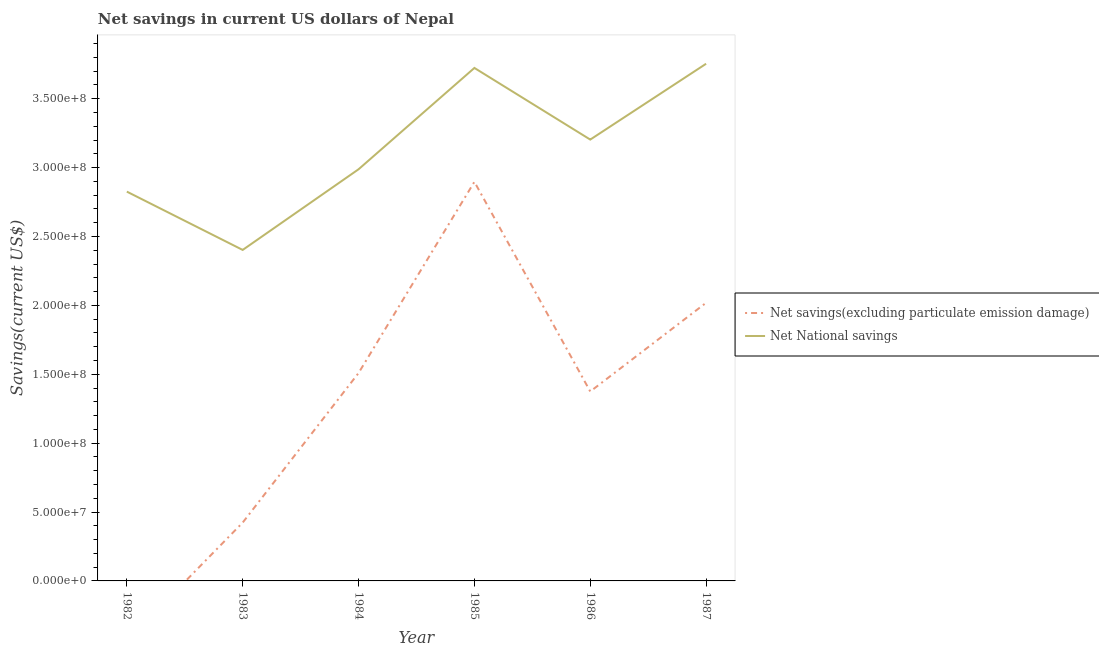How many different coloured lines are there?
Ensure brevity in your answer.  2. Does the line corresponding to net savings(excluding particulate emission damage) intersect with the line corresponding to net national savings?
Provide a short and direct response. No. Is the number of lines equal to the number of legend labels?
Offer a terse response. No. What is the net national savings in 1987?
Provide a succinct answer. 3.75e+08. Across all years, what is the maximum net savings(excluding particulate emission damage)?
Provide a short and direct response. 2.90e+08. Across all years, what is the minimum net national savings?
Your response must be concise. 2.40e+08. In which year was the net national savings maximum?
Keep it short and to the point. 1987. What is the total net national savings in the graph?
Provide a short and direct response. 1.89e+09. What is the difference between the net savings(excluding particulate emission damage) in 1983 and that in 1984?
Provide a short and direct response. -1.09e+08. What is the difference between the net savings(excluding particulate emission damage) in 1984 and the net national savings in 1985?
Provide a short and direct response. -2.21e+08. What is the average net savings(excluding particulate emission damage) per year?
Offer a very short reply. 1.37e+08. In the year 1986, what is the difference between the net national savings and net savings(excluding particulate emission damage)?
Ensure brevity in your answer.  1.83e+08. What is the ratio of the net savings(excluding particulate emission damage) in 1983 to that in 1984?
Provide a succinct answer. 0.28. Is the difference between the net savings(excluding particulate emission damage) in 1983 and 1984 greater than the difference between the net national savings in 1983 and 1984?
Provide a succinct answer. No. What is the difference between the highest and the second highest net savings(excluding particulate emission damage)?
Provide a short and direct response. 8.78e+07. What is the difference between the highest and the lowest net national savings?
Make the answer very short. 1.35e+08. How many lines are there?
Offer a terse response. 2. Are the values on the major ticks of Y-axis written in scientific E-notation?
Make the answer very short. Yes. How many legend labels are there?
Offer a terse response. 2. What is the title of the graph?
Provide a succinct answer. Net savings in current US dollars of Nepal. Does "Revenue" appear as one of the legend labels in the graph?
Keep it short and to the point. No. What is the label or title of the X-axis?
Keep it short and to the point. Year. What is the label or title of the Y-axis?
Make the answer very short. Savings(current US$). What is the Savings(current US$) in Net savings(excluding particulate emission damage) in 1982?
Your response must be concise. 0. What is the Savings(current US$) of Net National savings in 1982?
Offer a very short reply. 2.83e+08. What is the Savings(current US$) in Net savings(excluding particulate emission damage) in 1983?
Give a very brief answer. 4.23e+07. What is the Savings(current US$) in Net National savings in 1983?
Your answer should be very brief. 2.40e+08. What is the Savings(current US$) of Net savings(excluding particulate emission damage) in 1984?
Give a very brief answer. 1.51e+08. What is the Savings(current US$) in Net National savings in 1984?
Your answer should be very brief. 2.99e+08. What is the Savings(current US$) in Net savings(excluding particulate emission damage) in 1985?
Provide a succinct answer. 2.90e+08. What is the Savings(current US$) of Net National savings in 1985?
Give a very brief answer. 3.72e+08. What is the Savings(current US$) of Net savings(excluding particulate emission damage) in 1986?
Ensure brevity in your answer.  1.38e+08. What is the Savings(current US$) in Net National savings in 1986?
Ensure brevity in your answer.  3.20e+08. What is the Savings(current US$) of Net savings(excluding particulate emission damage) in 1987?
Ensure brevity in your answer.  2.02e+08. What is the Savings(current US$) in Net National savings in 1987?
Provide a succinct answer. 3.75e+08. Across all years, what is the maximum Savings(current US$) in Net savings(excluding particulate emission damage)?
Provide a short and direct response. 2.90e+08. Across all years, what is the maximum Savings(current US$) of Net National savings?
Offer a terse response. 3.75e+08. Across all years, what is the minimum Savings(current US$) in Net National savings?
Keep it short and to the point. 2.40e+08. What is the total Savings(current US$) of Net savings(excluding particulate emission damage) in the graph?
Ensure brevity in your answer.  8.22e+08. What is the total Savings(current US$) of Net National savings in the graph?
Keep it short and to the point. 1.89e+09. What is the difference between the Savings(current US$) in Net National savings in 1982 and that in 1983?
Your response must be concise. 4.23e+07. What is the difference between the Savings(current US$) in Net National savings in 1982 and that in 1984?
Offer a terse response. -1.62e+07. What is the difference between the Savings(current US$) in Net National savings in 1982 and that in 1985?
Your answer should be compact. -8.98e+07. What is the difference between the Savings(current US$) in Net National savings in 1982 and that in 1986?
Provide a succinct answer. -3.78e+07. What is the difference between the Savings(current US$) of Net National savings in 1982 and that in 1987?
Ensure brevity in your answer.  -9.28e+07. What is the difference between the Savings(current US$) in Net savings(excluding particulate emission damage) in 1983 and that in 1984?
Ensure brevity in your answer.  -1.09e+08. What is the difference between the Savings(current US$) of Net National savings in 1983 and that in 1984?
Your answer should be compact. -5.85e+07. What is the difference between the Savings(current US$) of Net savings(excluding particulate emission damage) in 1983 and that in 1985?
Make the answer very short. -2.47e+08. What is the difference between the Savings(current US$) of Net National savings in 1983 and that in 1985?
Offer a terse response. -1.32e+08. What is the difference between the Savings(current US$) of Net savings(excluding particulate emission damage) in 1983 and that in 1986?
Ensure brevity in your answer.  -9.52e+07. What is the difference between the Savings(current US$) of Net National savings in 1983 and that in 1986?
Give a very brief answer. -8.01e+07. What is the difference between the Savings(current US$) of Net savings(excluding particulate emission damage) in 1983 and that in 1987?
Provide a succinct answer. -1.60e+08. What is the difference between the Savings(current US$) in Net National savings in 1983 and that in 1987?
Offer a very short reply. -1.35e+08. What is the difference between the Savings(current US$) in Net savings(excluding particulate emission damage) in 1984 and that in 1985?
Give a very brief answer. -1.39e+08. What is the difference between the Savings(current US$) in Net National savings in 1984 and that in 1985?
Give a very brief answer. -7.36e+07. What is the difference between the Savings(current US$) in Net savings(excluding particulate emission damage) in 1984 and that in 1986?
Your answer should be very brief. 1.34e+07. What is the difference between the Savings(current US$) of Net National savings in 1984 and that in 1986?
Offer a terse response. -2.16e+07. What is the difference between the Savings(current US$) in Net savings(excluding particulate emission damage) in 1984 and that in 1987?
Provide a succinct answer. -5.10e+07. What is the difference between the Savings(current US$) in Net National savings in 1984 and that in 1987?
Your answer should be compact. -7.66e+07. What is the difference between the Savings(current US$) in Net savings(excluding particulate emission damage) in 1985 and that in 1986?
Offer a very short reply. 1.52e+08. What is the difference between the Savings(current US$) of Net National savings in 1985 and that in 1986?
Keep it short and to the point. 5.20e+07. What is the difference between the Savings(current US$) of Net savings(excluding particulate emission damage) in 1985 and that in 1987?
Give a very brief answer. 8.78e+07. What is the difference between the Savings(current US$) of Net National savings in 1985 and that in 1987?
Offer a very short reply. -3.04e+06. What is the difference between the Savings(current US$) of Net savings(excluding particulate emission damage) in 1986 and that in 1987?
Your answer should be compact. -6.44e+07. What is the difference between the Savings(current US$) of Net National savings in 1986 and that in 1987?
Keep it short and to the point. -5.51e+07. What is the difference between the Savings(current US$) of Net savings(excluding particulate emission damage) in 1983 and the Savings(current US$) of Net National savings in 1984?
Offer a terse response. -2.56e+08. What is the difference between the Savings(current US$) in Net savings(excluding particulate emission damage) in 1983 and the Savings(current US$) in Net National savings in 1985?
Provide a succinct answer. -3.30e+08. What is the difference between the Savings(current US$) in Net savings(excluding particulate emission damage) in 1983 and the Savings(current US$) in Net National savings in 1986?
Make the answer very short. -2.78e+08. What is the difference between the Savings(current US$) in Net savings(excluding particulate emission damage) in 1983 and the Savings(current US$) in Net National savings in 1987?
Ensure brevity in your answer.  -3.33e+08. What is the difference between the Savings(current US$) in Net savings(excluding particulate emission damage) in 1984 and the Savings(current US$) in Net National savings in 1985?
Give a very brief answer. -2.21e+08. What is the difference between the Savings(current US$) of Net savings(excluding particulate emission damage) in 1984 and the Savings(current US$) of Net National savings in 1986?
Keep it short and to the point. -1.69e+08. What is the difference between the Savings(current US$) in Net savings(excluding particulate emission damage) in 1984 and the Savings(current US$) in Net National savings in 1987?
Provide a succinct answer. -2.24e+08. What is the difference between the Savings(current US$) in Net savings(excluding particulate emission damage) in 1985 and the Savings(current US$) in Net National savings in 1986?
Offer a terse response. -3.07e+07. What is the difference between the Savings(current US$) in Net savings(excluding particulate emission damage) in 1985 and the Savings(current US$) in Net National savings in 1987?
Your answer should be very brief. -8.57e+07. What is the difference between the Savings(current US$) of Net savings(excluding particulate emission damage) in 1986 and the Savings(current US$) of Net National savings in 1987?
Your answer should be compact. -2.38e+08. What is the average Savings(current US$) of Net savings(excluding particulate emission damage) per year?
Your answer should be compact. 1.37e+08. What is the average Savings(current US$) of Net National savings per year?
Your response must be concise. 3.15e+08. In the year 1983, what is the difference between the Savings(current US$) in Net savings(excluding particulate emission damage) and Savings(current US$) in Net National savings?
Keep it short and to the point. -1.98e+08. In the year 1984, what is the difference between the Savings(current US$) in Net savings(excluding particulate emission damage) and Savings(current US$) in Net National savings?
Offer a terse response. -1.48e+08. In the year 1985, what is the difference between the Savings(current US$) of Net savings(excluding particulate emission damage) and Savings(current US$) of Net National savings?
Offer a terse response. -8.27e+07. In the year 1986, what is the difference between the Savings(current US$) in Net savings(excluding particulate emission damage) and Savings(current US$) in Net National savings?
Keep it short and to the point. -1.83e+08. In the year 1987, what is the difference between the Savings(current US$) in Net savings(excluding particulate emission damage) and Savings(current US$) in Net National savings?
Ensure brevity in your answer.  -1.74e+08. What is the ratio of the Savings(current US$) in Net National savings in 1982 to that in 1983?
Provide a short and direct response. 1.18. What is the ratio of the Savings(current US$) in Net National savings in 1982 to that in 1984?
Make the answer very short. 0.95. What is the ratio of the Savings(current US$) of Net National savings in 1982 to that in 1985?
Offer a terse response. 0.76. What is the ratio of the Savings(current US$) of Net National savings in 1982 to that in 1986?
Give a very brief answer. 0.88. What is the ratio of the Savings(current US$) in Net National savings in 1982 to that in 1987?
Your response must be concise. 0.75. What is the ratio of the Savings(current US$) in Net savings(excluding particulate emission damage) in 1983 to that in 1984?
Make the answer very short. 0.28. What is the ratio of the Savings(current US$) of Net National savings in 1983 to that in 1984?
Provide a succinct answer. 0.8. What is the ratio of the Savings(current US$) in Net savings(excluding particulate emission damage) in 1983 to that in 1985?
Provide a short and direct response. 0.15. What is the ratio of the Savings(current US$) of Net National savings in 1983 to that in 1985?
Provide a succinct answer. 0.65. What is the ratio of the Savings(current US$) of Net savings(excluding particulate emission damage) in 1983 to that in 1986?
Ensure brevity in your answer.  0.31. What is the ratio of the Savings(current US$) of Net National savings in 1983 to that in 1986?
Your response must be concise. 0.75. What is the ratio of the Savings(current US$) of Net savings(excluding particulate emission damage) in 1983 to that in 1987?
Your response must be concise. 0.21. What is the ratio of the Savings(current US$) of Net National savings in 1983 to that in 1987?
Provide a succinct answer. 0.64. What is the ratio of the Savings(current US$) in Net savings(excluding particulate emission damage) in 1984 to that in 1985?
Provide a short and direct response. 0.52. What is the ratio of the Savings(current US$) of Net National savings in 1984 to that in 1985?
Your answer should be very brief. 0.8. What is the ratio of the Savings(current US$) in Net savings(excluding particulate emission damage) in 1984 to that in 1986?
Your answer should be very brief. 1.1. What is the ratio of the Savings(current US$) in Net National savings in 1984 to that in 1986?
Give a very brief answer. 0.93. What is the ratio of the Savings(current US$) in Net savings(excluding particulate emission damage) in 1984 to that in 1987?
Give a very brief answer. 0.75. What is the ratio of the Savings(current US$) of Net National savings in 1984 to that in 1987?
Give a very brief answer. 0.8. What is the ratio of the Savings(current US$) in Net savings(excluding particulate emission damage) in 1985 to that in 1986?
Make the answer very short. 2.11. What is the ratio of the Savings(current US$) of Net National savings in 1985 to that in 1986?
Your answer should be compact. 1.16. What is the ratio of the Savings(current US$) in Net savings(excluding particulate emission damage) in 1985 to that in 1987?
Your answer should be compact. 1.43. What is the ratio of the Savings(current US$) in Net savings(excluding particulate emission damage) in 1986 to that in 1987?
Make the answer very short. 0.68. What is the ratio of the Savings(current US$) in Net National savings in 1986 to that in 1987?
Provide a short and direct response. 0.85. What is the difference between the highest and the second highest Savings(current US$) of Net savings(excluding particulate emission damage)?
Give a very brief answer. 8.78e+07. What is the difference between the highest and the second highest Savings(current US$) of Net National savings?
Ensure brevity in your answer.  3.04e+06. What is the difference between the highest and the lowest Savings(current US$) in Net savings(excluding particulate emission damage)?
Provide a succinct answer. 2.90e+08. What is the difference between the highest and the lowest Savings(current US$) of Net National savings?
Give a very brief answer. 1.35e+08. 